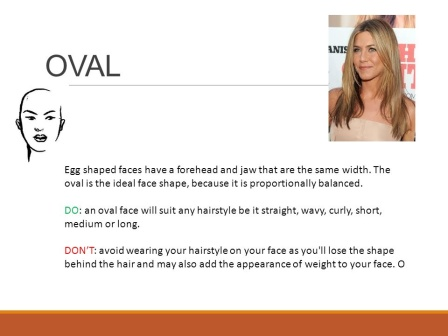What do you think is going on in this snapshot?
 The image is a slide from a presentation, focusing on face shapes and hairstyles. It's divided into two sections. On the left, there's a black and white illustration of an oval face shape. The right side features a photo of a woman with an oval face shape and long blonde hair. The slide includes text that explains the characteristics of an oval face shape and offers advice on hairstyles that suit this face shape. The visible text in the image reads "OVAL Egg shaped faces have a forehead and jaw that are the". The rest of the text is not visible in the image. The woman in the photo is looking straight at the camera, her long blonde hair cascading down her shoulders. The slide seems to be part of an educational or informative presentation, possibly for a beauty or hairstyling seminar. The overall tone is professional and informative. 